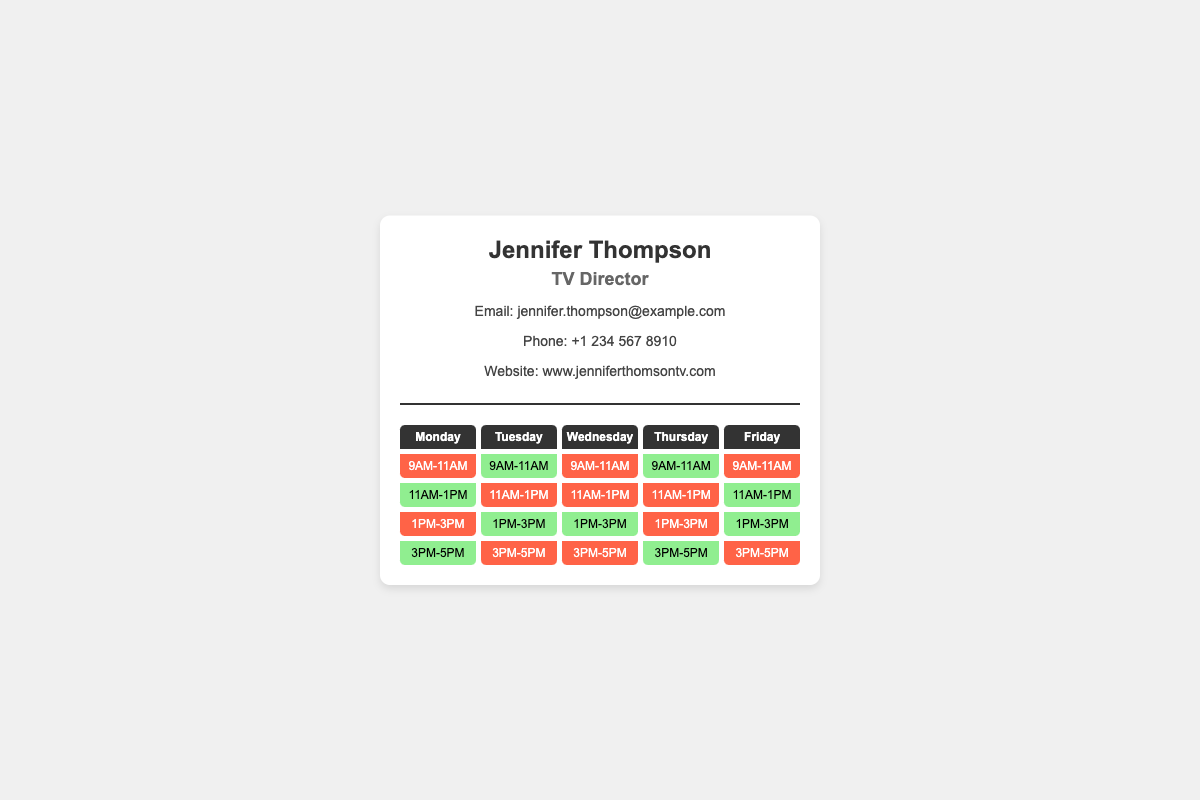What is the name on the business card? The name displayed at the top of the business card is Jennifer Thompson.
Answer: Jennifer Thompson What is Jennifer Thompson's profession? The document indicates her profession right below her name.
Answer: TV Director What is the email address listed on the card? The email address is mentioned in the contact information section.
Answer: jennifer.thompson@example.com How many days are shown in the schedule? The schedule grid contains days of the week, and there are five days presented.
Answer: 5 What time slot is free on Tuesday? Observing the time slots for Tuesday allows identification of availability.
Answer: 1PM-3PM How many afternoon time slots are busy on Wednesday? By checking the time slots for Wednesday, we can count the busy periods in the afternoon.
Answer: 2 Which day has a free slot for 3PM to 5PM? The schedule shows the availability for this time frame which can be found by examining the grid.
Answer: Thursday What color represents busy slots? The color coding system is intended for easy identification to distinguish availability.
Answer: Red What is the website mentioned on the card? The card details include a professional website at the bottom through which she can be contacted.
Answer: www.jenniferthomsontv.com 